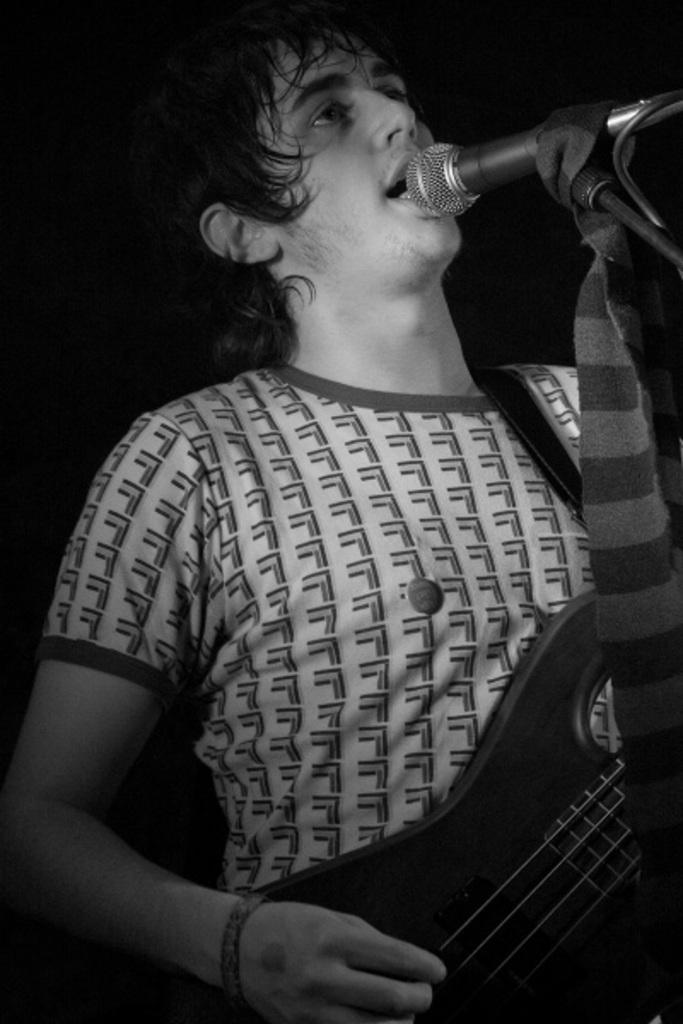How would you summarize this image in a sentence or two? In the image we can see there is a man who is holding a guitar in his hand and in front of him there is a mike and the image is in black and white colour. 